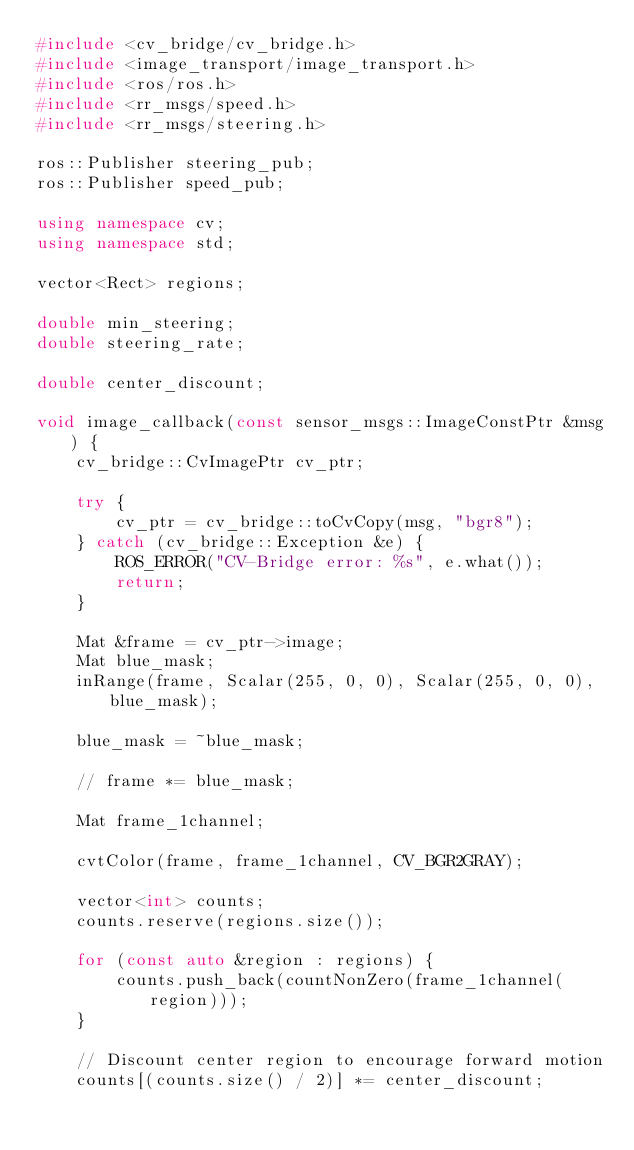<code> <loc_0><loc_0><loc_500><loc_500><_C++_>#include <cv_bridge/cv_bridge.h>
#include <image_transport/image_transport.h>
#include <ros/ros.h>
#include <rr_msgs/speed.h>
#include <rr_msgs/steering.h>

ros::Publisher steering_pub;
ros::Publisher speed_pub;

using namespace cv;
using namespace std;

vector<Rect> regions;

double min_steering;
double steering_rate;

double center_discount;

void image_callback(const sensor_msgs::ImageConstPtr &msg) {
    cv_bridge::CvImagePtr cv_ptr;

    try {
        cv_ptr = cv_bridge::toCvCopy(msg, "bgr8");
    } catch (cv_bridge::Exception &e) {
        ROS_ERROR("CV-Bridge error: %s", e.what());
        return;
    }

    Mat &frame = cv_ptr->image;
    Mat blue_mask;
    inRange(frame, Scalar(255, 0, 0), Scalar(255, 0, 0), blue_mask);

    blue_mask = ~blue_mask;

    // frame *= blue_mask;

    Mat frame_1channel;

    cvtColor(frame, frame_1channel, CV_BGR2GRAY);

    vector<int> counts;
    counts.reserve(regions.size());

    for (const auto &region : regions) {
        counts.push_back(countNonZero(frame_1channel(region)));
    }

    // Discount center region to encourage forward motion
    counts[(counts.size() / 2)] *= center_discount;
</code> 